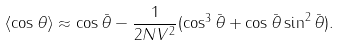<formula> <loc_0><loc_0><loc_500><loc_500>\langle \cos \theta \rangle \approx \cos \bar { \theta } - \frac { 1 } { 2 N V ^ { 2 } } ( \cos ^ { 3 } \bar { \theta } + \cos \bar { \theta } \sin ^ { 2 } \bar { \theta } ) .</formula> 